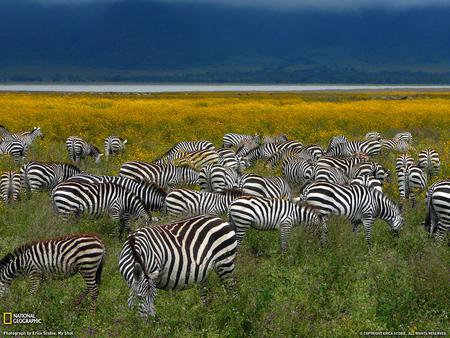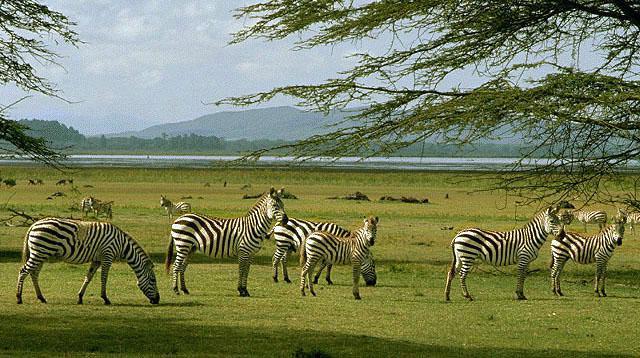The first image is the image on the left, the second image is the image on the right. For the images displayed, is the sentence "The right image features a row of zebras with their bodies facing rightward." factually correct? Answer yes or no. Yes. The first image is the image on the left, the second image is the image on the right. Considering the images on both sides, is "In at least one image is a row of zebra going right and in the other image there is is a large group of zebra in different directions." valid? Answer yes or no. Yes. 